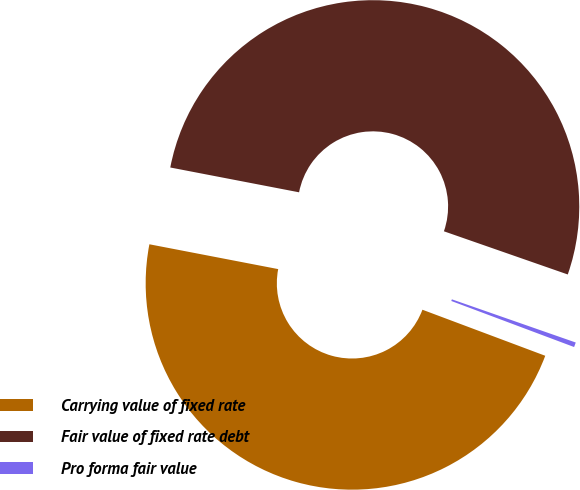<chart> <loc_0><loc_0><loc_500><loc_500><pie_chart><fcel>Carrying value of fixed rate<fcel>Fair value of fixed rate debt<fcel>Pro forma fair value<nl><fcel>47.32%<fcel>52.31%<fcel>0.37%<nl></chart> 